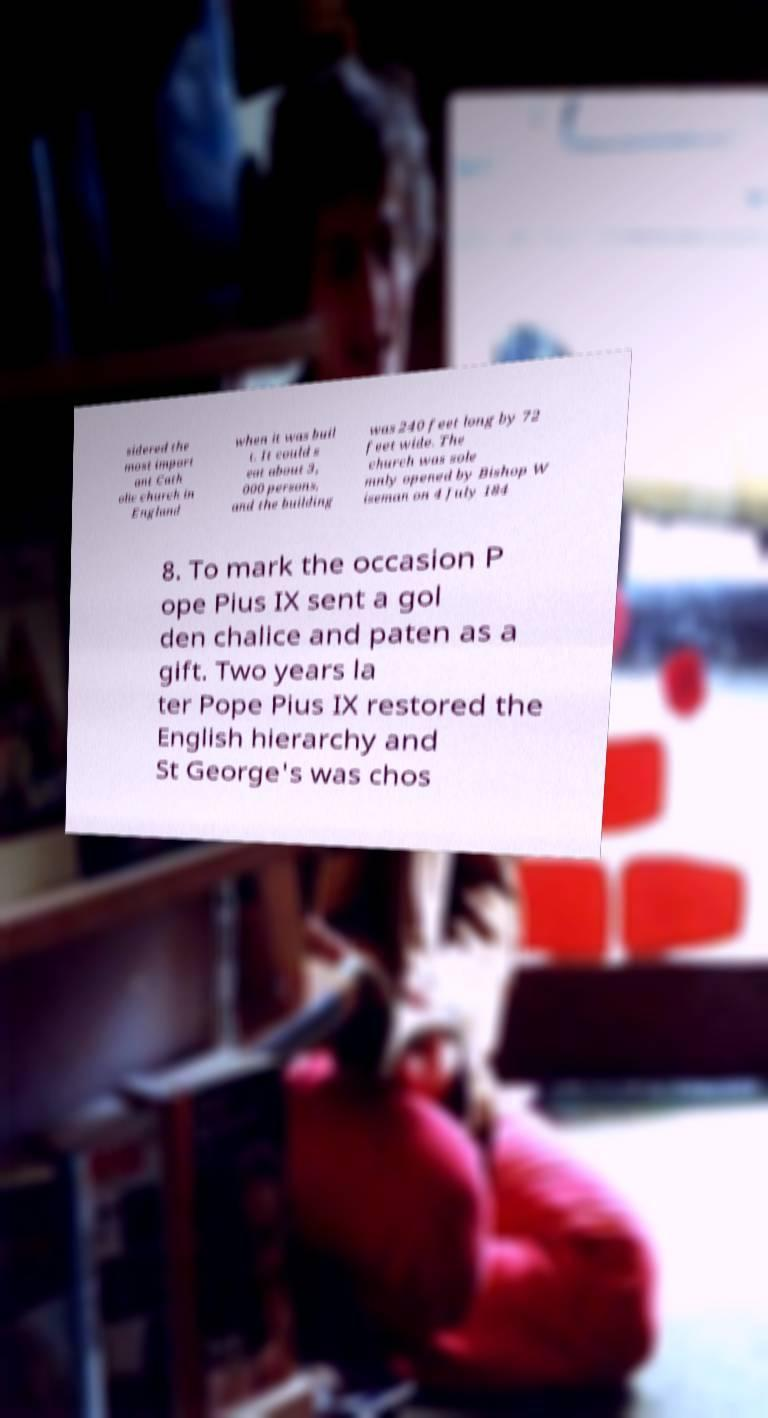Could you extract and type out the text from this image? sidered the most import ant Cath olic church in England when it was buil t. It could s eat about 3, 000 persons, and the building was 240 feet long by 72 feet wide. The church was sole mnly opened by Bishop W iseman on 4 July 184 8. To mark the occasion P ope Pius IX sent a gol den chalice and paten as a gift. Two years la ter Pope Pius IX restored the English hierarchy and St George's was chos 